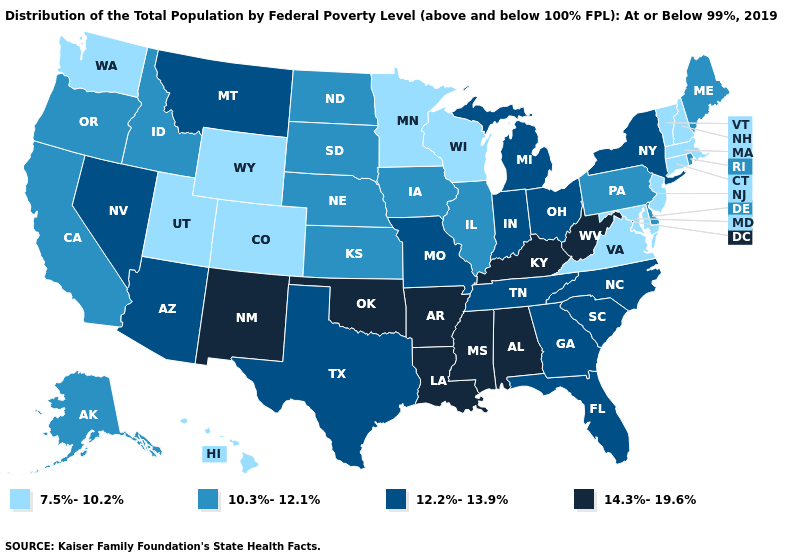What is the value of Arkansas?
Keep it brief. 14.3%-19.6%. Name the states that have a value in the range 12.2%-13.9%?
Quick response, please. Arizona, Florida, Georgia, Indiana, Michigan, Missouri, Montana, Nevada, New York, North Carolina, Ohio, South Carolina, Tennessee, Texas. Among the states that border Massachusetts , does Rhode Island have the highest value?
Quick response, please. No. Does Nevada have a higher value than Arizona?
Quick response, please. No. Which states have the highest value in the USA?
Be succinct. Alabama, Arkansas, Kentucky, Louisiana, Mississippi, New Mexico, Oklahoma, West Virginia. Does California have the lowest value in the USA?
Be succinct. No. How many symbols are there in the legend?
Write a very short answer. 4. Does the map have missing data?
Short answer required. No. Which states have the highest value in the USA?
Quick response, please. Alabama, Arkansas, Kentucky, Louisiana, Mississippi, New Mexico, Oklahoma, West Virginia. Name the states that have a value in the range 7.5%-10.2%?
Concise answer only. Colorado, Connecticut, Hawaii, Maryland, Massachusetts, Minnesota, New Hampshire, New Jersey, Utah, Vermont, Virginia, Washington, Wisconsin, Wyoming. What is the value of Wyoming?
Keep it brief. 7.5%-10.2%. What is the highest value in the South ?
Quick response, please. 14.3%-19.6%. Does Colorado have the lowest value in the USA?
Be succinct. Yes. Name the states that have a value in the range 7.5%-10.2%?
Quick response, please. Colorado, Connecticut, Hawaii, Maryland, Massachusetts, Minnesota, New Hampshire, New Jersey, Utah, Vermont, Virginia, Washington, Wisconsin, Wyoming. Among the states that border California , does Nevada have the lowest value?
Be succinct. No. 